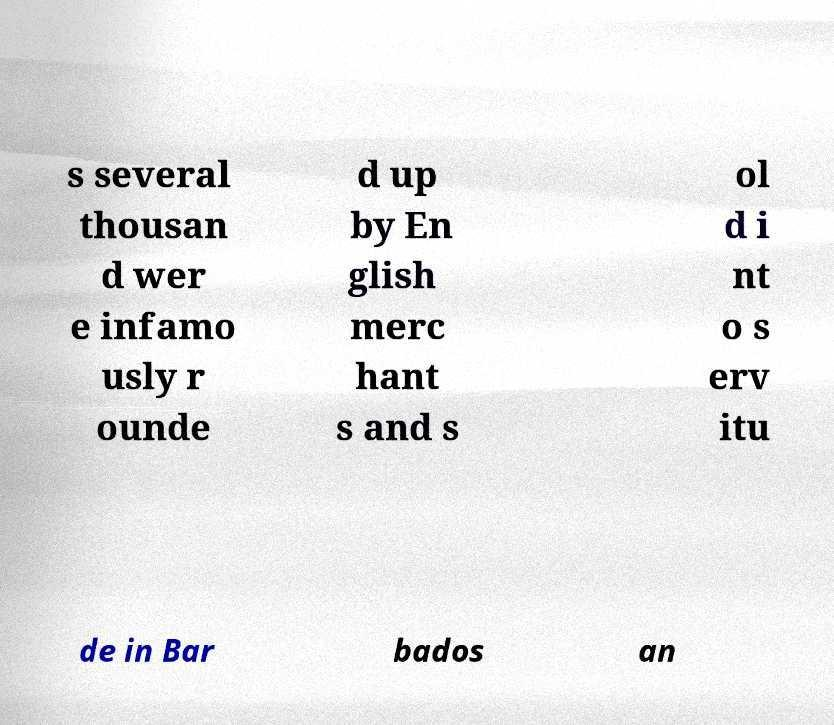Please identify and transcribe the text found in this image. s several thousan d wer e infamo usly r ounde d up by En glish merc hant s and s ol d i nt o s erv itu de in Bar bados an 